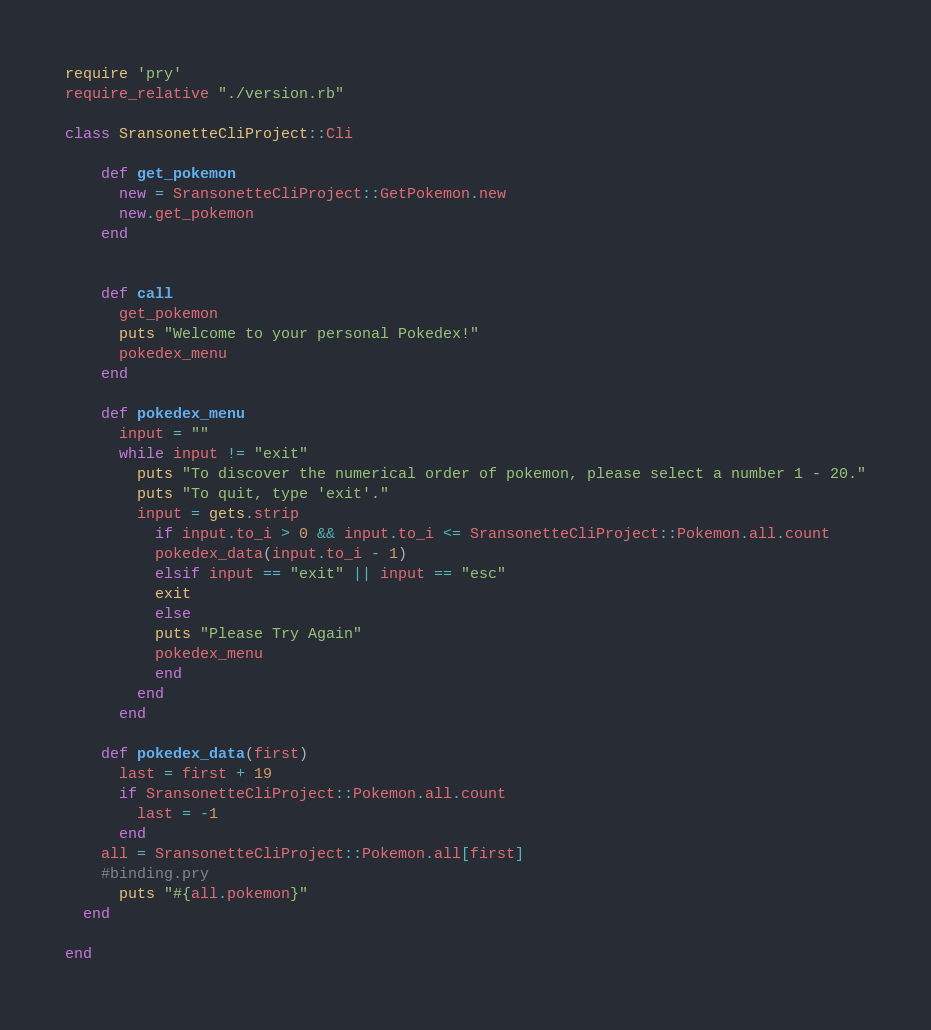Convert code to text. <code><loc_0><loc_0><loc_500><loc_500><_Ruby_>require 'pry'
require_relative "./version.rb"

class SransonetteCliProject::Cli 
  
    def get_pokemon
      new = SransonetteCliProject::GetPokemon.new 
      new.get_pokemon
    end
   
   
    def call  
      get_pokemon
      puts "Welcome to your personal Pokedex!"
      pokedex_menu
    end
    
    def pokedex_menu
      input = ""
      while input != "exit"
        puts "To discover the numerical order of pokemon, please select a number 1 - 20."
        puts "To quit, type 'exit'."
        input = gets.strip
          if input.to_i > 0 && input.to_i <= SransonetteCliProject::Pokemon.all.count
          pokedex_data(input.to_i - 1)
          elsif input == "exit" || input == "esc"
          exit
          else
          puts "Please Try Again"
          pokedex_menu
          end
        end
      end
      
    def pokedex_data(first)
      last = first + 19
      if SransonetteCliProject::Pokemon.all.count 
        last = -1
      end
    all = SransonetteCliProject::Pokemon.all[first]
    #binding.pry
      puts "#{all.pokemon}"
  end

end</code> 